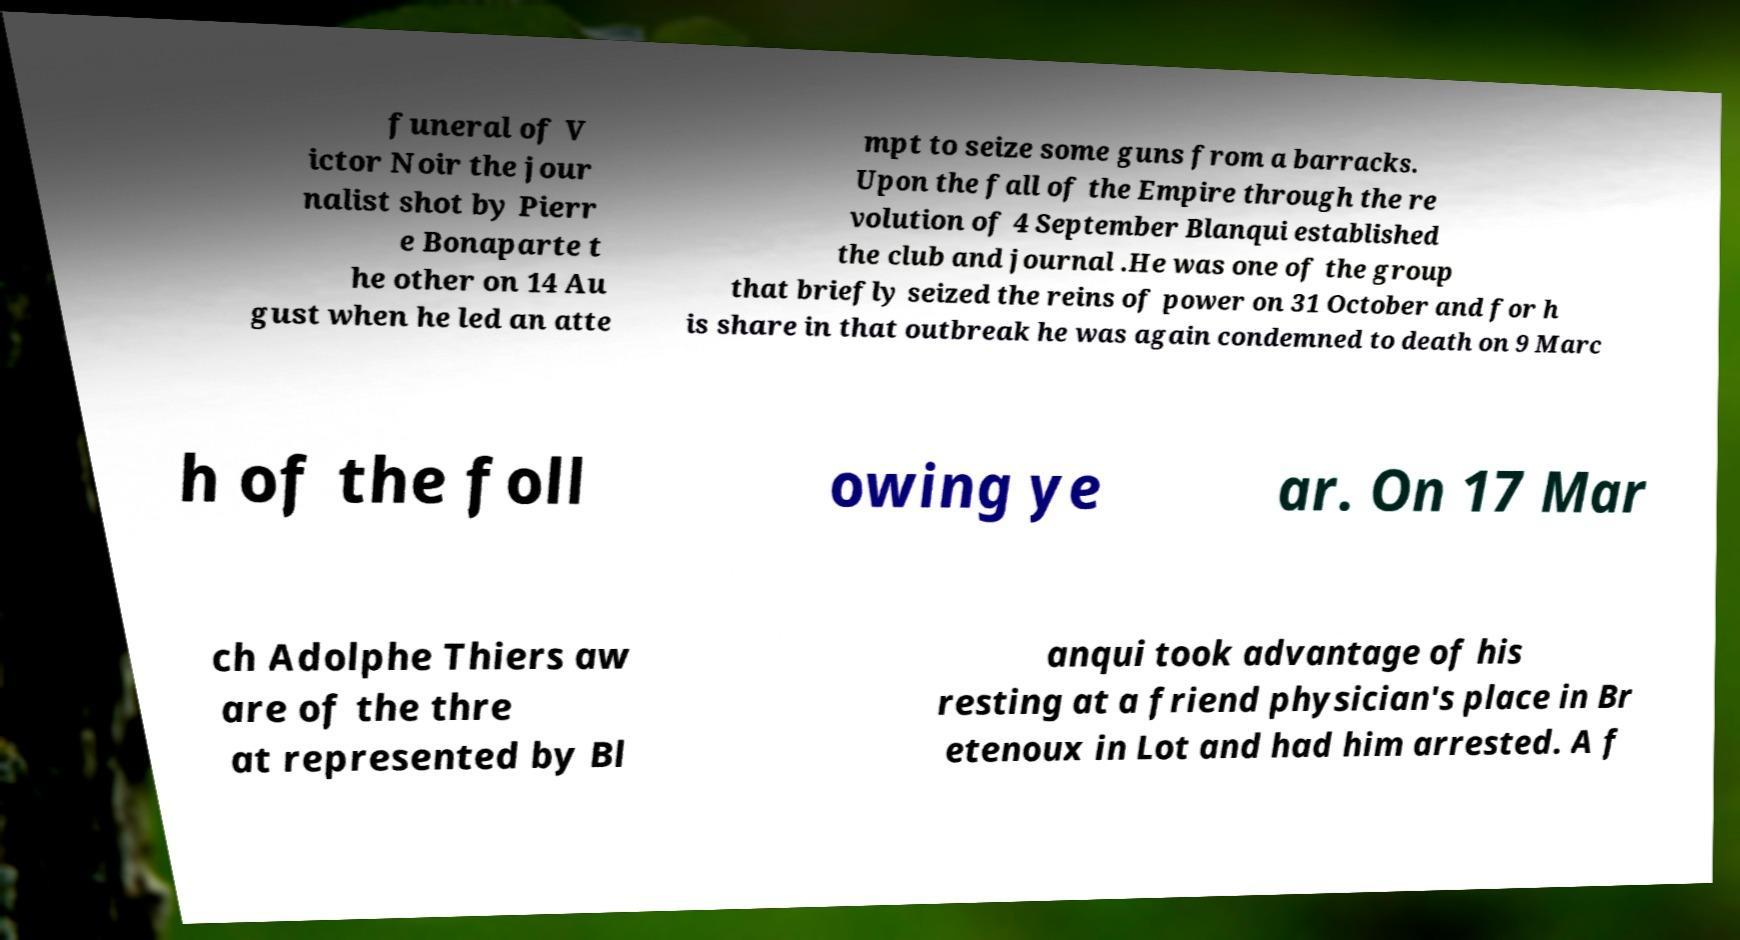Please read and relay the text visible in this image. What does it say? funeral of V ictor Noir the jour nalist shot by Pierr e Bonaparte t he other on 14 Au gust when he led an atte mpt to seize some guns from a barracks. Upon the fall of the Empire through the re volution of 4 September Blanqui established the club and journal .He was one of the group that briefly seized the reins of power on 31 October and for h is share in that outbreak he was again condemned to death on 9 Marc h of the foll owing ye ar. On 17 Mar ch Adolphe Thiers aw are of the thre at represented by Bl anqui took advantage of his resting at a friend physician's place in Br etenoux in Lot and had him arrested. A f 